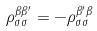Convert formula to latex. <formula><loc_0><loc_0><loc_500><loc_500>\rho ^ { \beta \beta ^ { \prime } } _ { \sigma \sigma } = - \rho ^ { \beta ^ { \prime } \beta } _ { \sigma \sigma }</formula> 